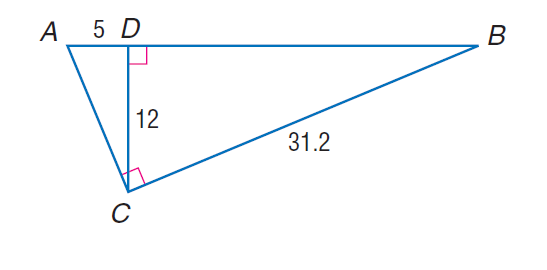Question: Find the perimeter of the \triangle A B C, if \triangle A B C \sim \triangle C B D, A D = 5, C D = 12, and B C = 31.2.
Choices:
A. 32.5
B. 72
C. 78
D. 187.2
Answer with the letter. Answer: C 